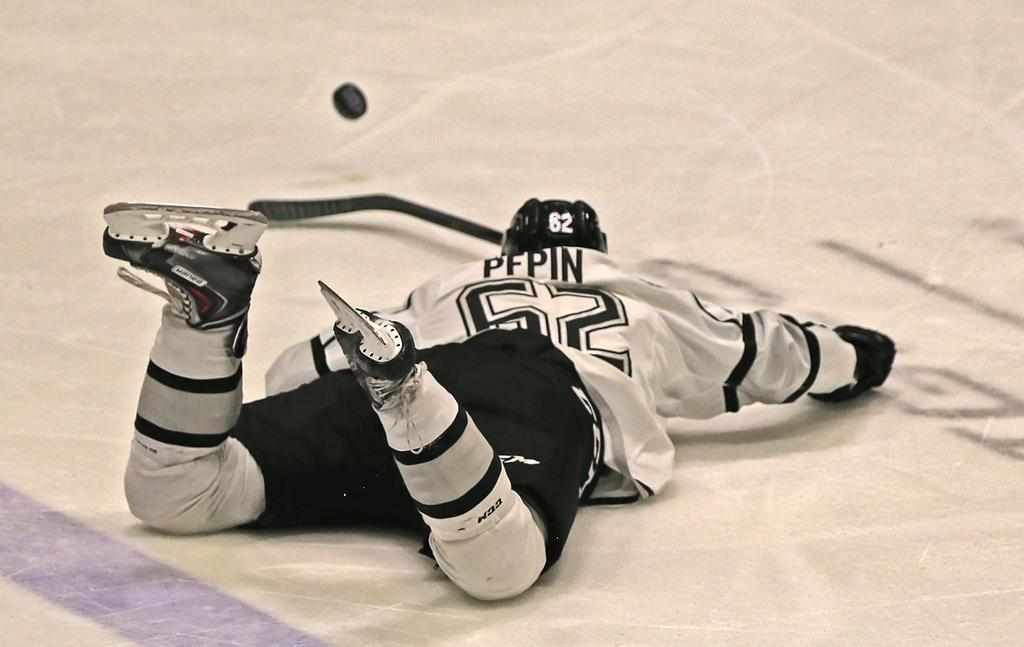<image>
Write a terse but informative summary of the picture. Pepin, who is number 52, is sprawled on the ice and looking at the puck nearby. 